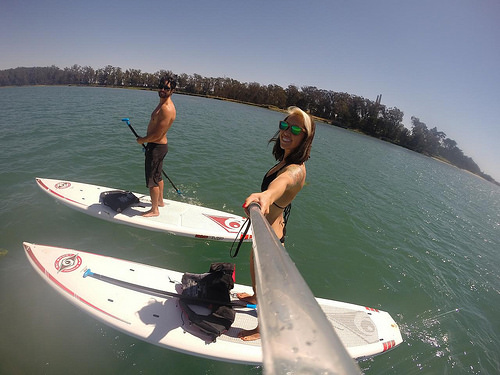<image>
Is there a women to the left of the man? Yes. From this viewpoint, the women is positioned to the left side relative to the man. 